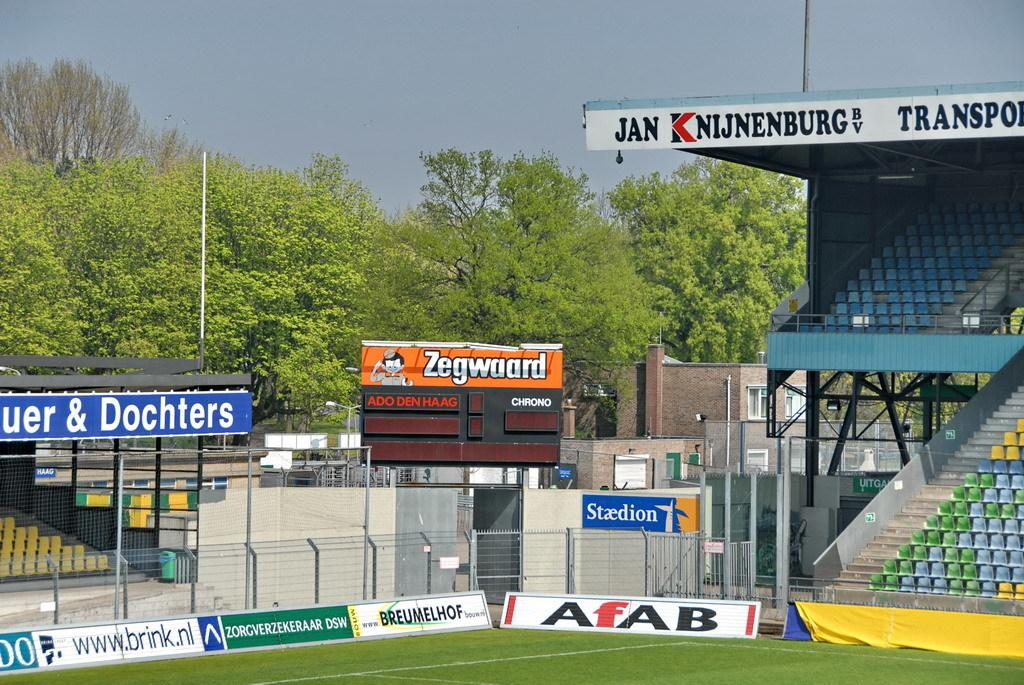<image>
Offer a succinct explanation of the picture presented. A sports field with empty stands and an advertisement for Afab. 